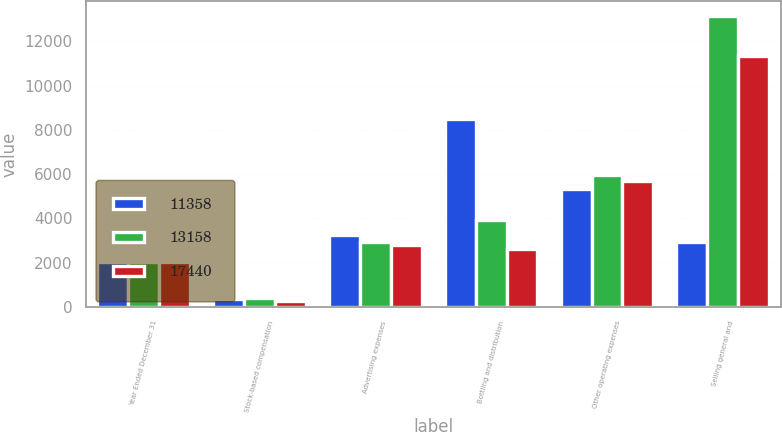Convert chart. <chart><loc_0><loc_0><loc_500><loc_500><stacked_bar_chart><ecel><fcel>Year Ended December 31<fcel>Stock-based compensation<fcel>Advertising expenses<fcel>Bottling and distribution<fcel>Other operating expenses<fcel>Selling general and<nl><fcel>11358<fcel>2011<fcel>354<fcel>3256<fcel>8501<fcel>5329<fcel>2917<nl><fcel>13158<fcel>2010<fcel>380<fcel>2917<fcel>3902<fcel>5959<fcel>13158<nl><fcel>17440<fcel>2009<fcel>241<fcel>2791<fcel>2627<fcel>5699<fcel>11358<nl></chart> 